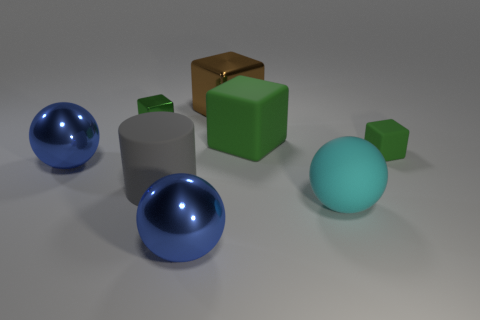There is a blue ball in front of the big thing that is left of the large gray matte cylinder; are there any cylinders that are on the right side of it?
Offer a very short reply. No. What number of things are on the right side of the cyan thing?
Provide a short and direct response. 1. How many shiny objects are the same color as the tiny matte thing?
Keep it short and to the point. 1. How many objects are either green blocks that are behind the tiny green rubber object or large shiny objects to the left of the tiny green shiny object?
Your answer should be compact. 3. Are there more big gray rubber cubes than gray rubber objects?
Keep it short and to the point. No. There is a tiny object on the left side of the gray cylinder; what is its color?
Your answer should be compact. Green. Is the shape of the big green matte object the same as the brown shiny thing?
Offer a terse response. Yes. The large metal object that is behind the big matte cylinder and right of the matte cylinder is what color?
Offer a very short reply. Brown. There is a green matte cube right of the cyan object; is its size the same as the shiny cube on the left side of the gray object?
Your answer should be very brief. Yes. What number of objects are either blue things that are on the right side of the green metal cube or green cylinders?
Give a very brief answer. 1. 